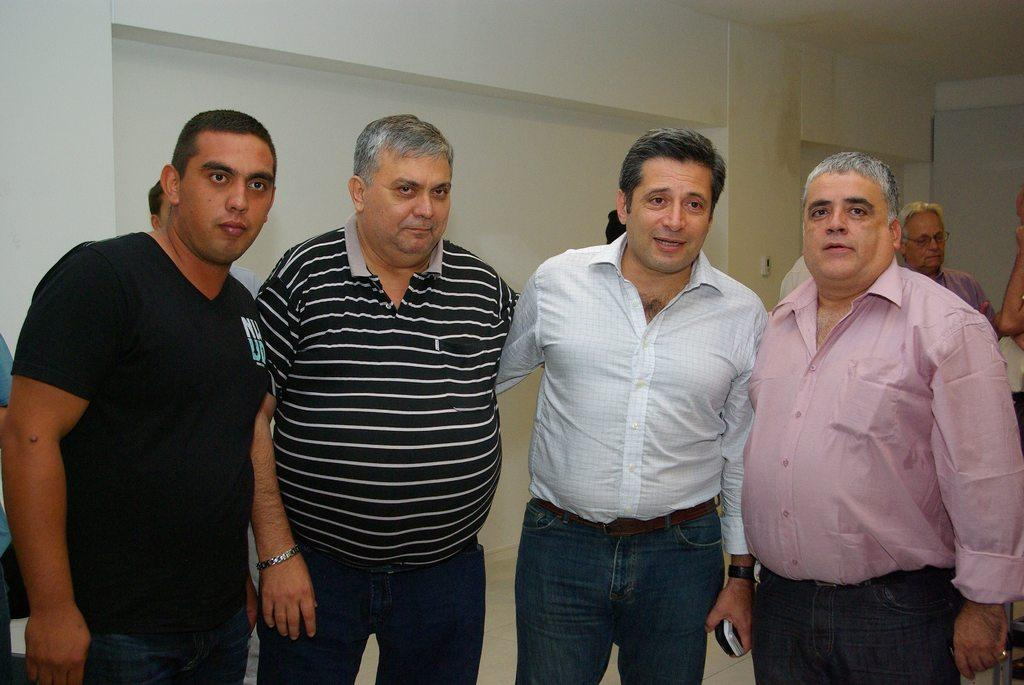How many people are standing in the image? There are four people standing in the image. Can you describe the people in the background of the image? There are people in the background of the image, but their specific characteristics are not mentioned in the facts. What is visible in the background of the image? There is a wall visible in the background of the image. What observation can be made about the grandfather in the image? There is no mention of a grandfather in the image or the facts provided. What does the caption say about the people in the image? There is no caption mentioned in the facts provided, so it is not possible to answer this question. 